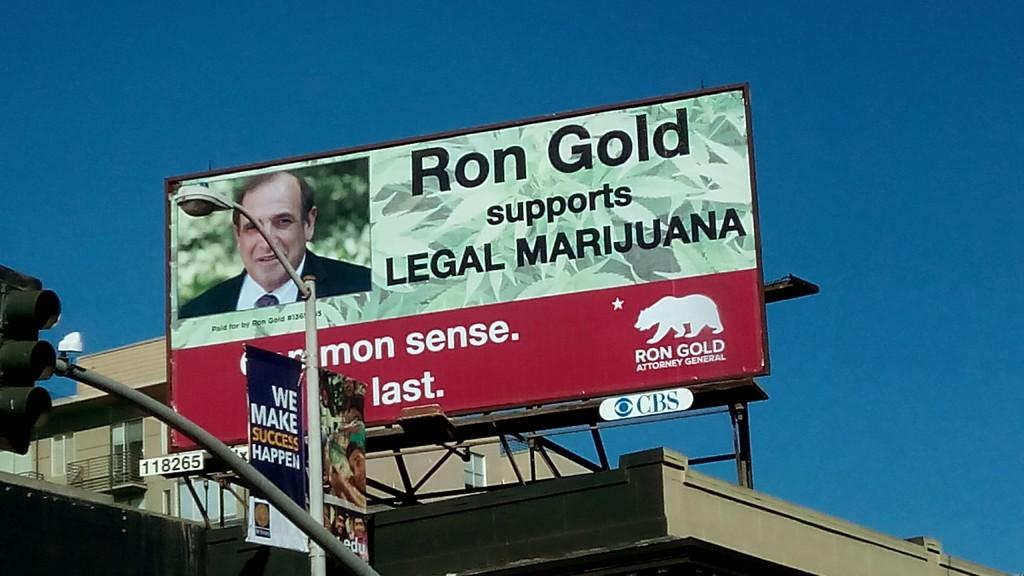<image>
Provide a brief description of the given image. A candidate named Ron Gold wants to legalize marijuana. 